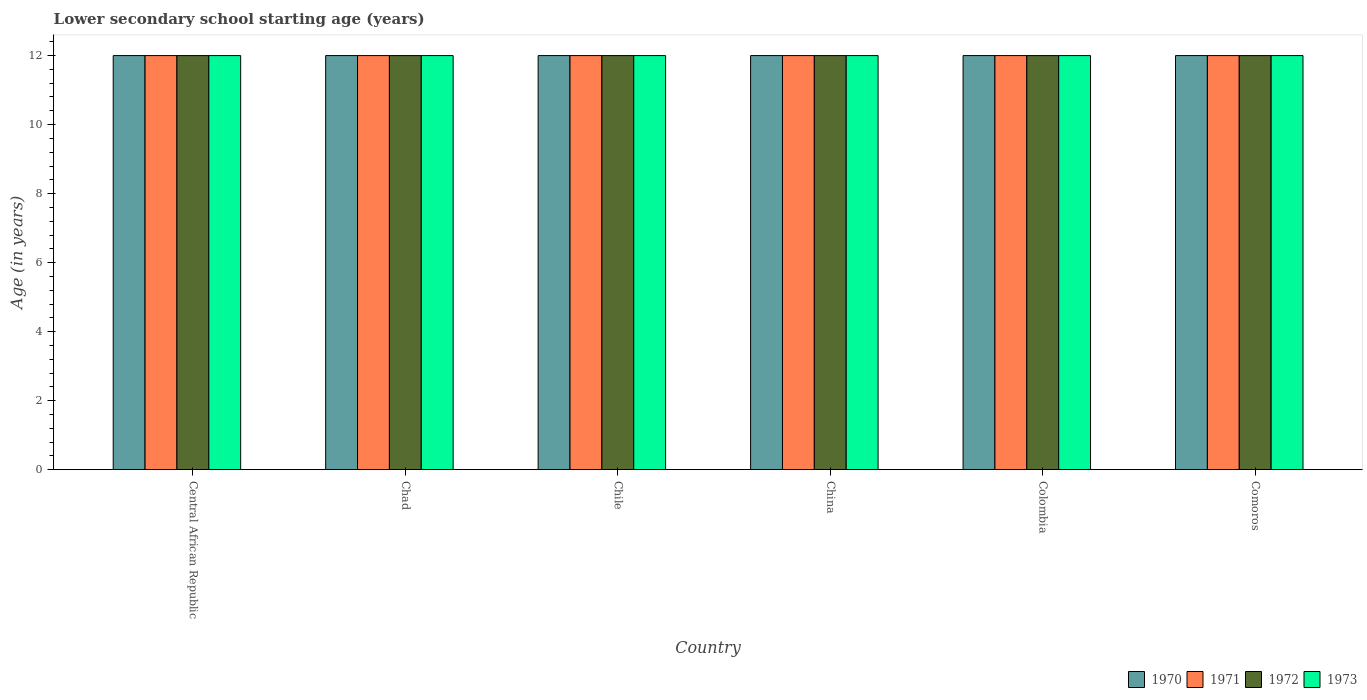Are the number of bars on each tick of the X-axis equal?
Provide a succinct answer. Yes. How many bars are there on the 4th tick from the left?
Offer a terse response. 4. In how many cases, is the number of bars for a given country not equal to the number of legend labels?
Keep it short and to the point. 0. Across all countries, what is the maximum lower secondary school starting age of children in 1971?
Keep it short and to the point. 12. In which country was the lower secondary school starting age of children in 1970 maximum?
Give a very brief answer. Central African Republic. In which country was the lower secondary school starting age of children in 1973 minimum?
Offer a terse response. Central African Republic. What is the difference between the lower secondary school starting age of children in 1971 in Colombia and the lower secondary school starting age of children in 1970 in Chile?
Your response must be concise. 0. What is the average lower secondary school starting age of children in 1970 per country?
Provide a short and direct response. 12. What is the difference between the lower secondary school starting age of children of/in 1971 and lower secondary school starting age of children of/in 1970 in Chile?
Give a very brief answer. 0. In how many countries, is the lower secondary school starting age of children in 1973 greater than 7.6 years?
Offer a terse response. 6. Is the difference between the lower secondary school starting age of children in 1971 in Central African Republic and Chile greater than the difference between the lower secondary school starting age of children in 1970 in Central African Republic and Chile?
Keep it short and to the point. No. What is the difference between the highest and the lowest lower secondary school starting age of children in 1971?
Ensure brevity in your answer.  0. Is the sum of the lower secondary school starting age of children in 1970 in Central African Republic and Comoros greater than the maximum lower secondary school starting age of children in 1971 across all countries?
Give a very brief answer. Yes. Is it the case that in every country, the sum of the lower secondary school starting age of children in 1973 and lower secondary school starting age of children in 1971 is greater than the sum of lower secondary school starting age of children in 1972 and lower secondary school starting age of children in 1970?
Provide a short and direct response. No. What is the difference between two consecutive major ticks on the Y-axis?
Your answer should be very brief. 2. Are the values on the major ticks of Y-axis written in scientific E-notation?
Your response must be concise. No. Does the graph contain grids?
Keep it short and to the point. No. How many legend labels are there?
Offer a very short reply. 4. How are the legend labels stacked?
Make the answer very short. Horizontal. What is the title of the graph?
Offer a very short reply. Lower secondary school starting age (years). What is the label or title of the Y-axis?
Keep it short and to the point. Age (in years). What is the Age (in years) in 1970 in Central African Republic?
Give a very brief answer. 12. What is the Age (in years) of 1972 in Central African Republic?
Give a very brief answer. 12. What is the Age (in years) in 1973 in Central African Republic?
Provide a succinct answer. 12. What is the Age (in years) of 1970 in Chad?
Offer a very short reply. 12. What is the Age (in years) of 1972 in Chad?
Your response must be concise. 12. What is the Age (in years) in 1973 in Chad?
Make the answer very short. 12. What is the Age (in years) in 1970 in Chile?
Offer a terse response. 12. What is the Age (in years) of 1970 in China?
Your answer should be very brief. 12. What is the Age (in years) in 1971 in China?
Offer a terse response. 12. What is the Age (in years) in 1973 in China?
Your answer should be compact. 12. What is the Age (in years) of 1972 in Colombia?
Your answer should be very brief. 12. What is the Age (in years) in 1973 in Colombia?
Give a very brief answer. 12. Across all countries, what is the maximum Age (in years) of 1970?
Offer a terse response. 12. Across all countries, what is the maximum Age (in years) in 1971?
Ensure brevity in your answer.  12. Across all countries, what is the minimum Age (in years) in 1970?
Give a very brief answer. 12. Across all countries, what is the minimum Age (in years) in 1971?
Offer a terse response. 12. What is the total Age (in years) in 1970 in the graph?
Your answer should be very brief. 72. What is the total Age (in years) of 1973 in the graph?
Your response must be concise. 72. What is the difference between the Age (in years) in 1970 in Central African Republic and that in Chad?
Provide a succinct answer. 0. What is the difference between the Age (in years) in 1971 in Central African Republic and that in Chad?
Your answer should be very brief. 0. What is the difference between the Age (in years) of 1972 in Central African Republic and that in Chad?
Keep it short and to the point. 0. What is the difference between the Age (in years) in 1973 in Central African Republic and that in Chad?
Your answer should be very brief. 0. What is the difference between the Age (in years) of 1971 in Central African Republic and that in Chile?
Offer a terse response. 0. What is the difference between the Age (in years) of 1970 in Central African Republic and that in China?
Give a very brief answer. 0. What is the difference between the Age (in years) of 1971 in Central African Republic and that in China?
Give a very brief answer. 0. What is the difference between the Age (in years) in 1973 in Central African Republic and that in China?
Offer a very short reply. 0. What is the difference between the Age (in years) of 1970 in Central African Republic and that in Colombia?
Keep it short and to the point. 0. What is the difference between the Age (in years) of 1972 in Central African Republic and that in Colombia?
Provide a succinct answer. 0. What is the difference between the Age (in years) in 1973 in Central African Republic and that in Colombia?
Ensure brevity in your answer.  0. What is the difference between the Age (in years) in 1970 in Central African Republic and that in Comoros?
Your answer should be very brief. 0. What is the difference between the Age (in years) in 1973 in Central African Republic and that in Comoros?
Ensure brevity in your answer.  0. What is the difference between the Age (in years) of 1971 in Chad and that in Chile?
Give a very brief answer. 0. What is the difference between the Age (in years) in 1972 in Chad and that in Chile?
Provide a short and direct response. 0. What is the difference between the Age (in years) of 1970 in Chad and that in China?
Your response must be concise. 0. What is the difference between the Age (in years) of 1972 in Chad and that in China?
Provide a short and direct response. 0. What is the difference between the Age (in years) of 1970 in Chad and that in Colombia?
Provide a succinct answer. 0. What is the difference between the Age (in years) in 1971 in Chad and that in Colombia?
Your response must be concise. 0. What is the difference between the Age (in years) in 1970 in Chad and that in Comoros?
Provide a succinct answer. 0. What is the difference between the Age (in years) in 1973 in Chad and that in Comoros?
Make the answer very short. 0. What is the difference between the Age (in years) of 1970 in Chile and that in China?
Your answer should be very brief. 0. What is the difference between the Age (in years) in 1971 in Chile and that in China?
Provide a succinct answer. 0. What is the difference between the Age (in years) in 1970 in Chile and that in Comoros?
Give a very brief answer. 0. What is the difference between the Age (in years) in 1972 in Chile and that in Comoros?
Your response must be concise. 0. What is the difference between the Age (in years) of 1973 in Chile and that in Comoros?
Your answer should be very brief. 0. What is the difference between the Age (in years) in 1970 in China and that in Colombia?
Give a very brief answer. 0. What is the difference between the Age (in years) of 1971 in China and that in Colombia?
Offer a terse response. 0. What is the difference between the Age (in years) in 1972 in China and that in Colombia?
Ensure brevity in your answer.  0. What is the difference between the Age (in years) in 1970 in China and that in Comoros?
Provide a succinct answer. 0. What is the difference between the Age (in years) of 1971 in China and that in Comoros?
Provide a succinct answer. 0. What is the difference between the Age (in years) of 1973 in China and that in Comoros?
Your answer should be very brief. 0. What is the difference between the Age (in years) in 1970 in Colombia and that in Comoros?
Your answer should be compact. 0. What is the difference between the Age (in years) in 1971 in Colombia and that in Comoros?
Provide a succinct answer. 0. What is the difference between the Age (in years) in 1972 in Colombia and that in Comoros?
Your answer should be compact. 0. What is the difference between the Age (in years) in 1970 in Central African Republic and the Age (in years) in 1971 in Chad?
Ensure brevity in your answer.  0. What is the difference between the Age (in years) in 1970 in Central African Republic and the Age (in years) in 1973 in Chad?
Your response must be concise. 0. What is the difference between the Age (in years) in 1971 in Central African Republic and the Age (in years) in 1972 in Chad?
Your answer should be compact. 0. What is the difference between the Age (in years) in 1971 in Central African Republic and the Age (in years) in 1973 in Chad?
Provide a short and direct response. 0. What is the difference between the Age (in years) of 1970 in Central African Republic and the Age (in years) of 1972 in Chile?
Ensure brevity in your answer.  0. What is the difference between the Age (in years) of 1972 in Central African Republic and the Age (in years) of 1973 in Chile?
Give a very brief answer. 0. What is the difference between the Age (in years) in 1972 in Central African Republic and the Age (in years) in 1973 in China?
Ensure brevity in your answer.  0. What is the difference between the Age (in years) in 1970 in Central African Republic and the Age (in years) in 1972 in Colombia?
Offer a terse response. 0. What is the difference between the Age (in years) of 1971 in Central African Republic and the Age (in years) of 1972 in Colombia?
Ensure brevity in your answer.  0. What is the difference between the Age (in years) in 1971 in Central African Republic and the Age (in years) in 1973 in Colombia?
Make the answer very short. 0. What is the difference between the Age (in years) in 1970 in Central African Republic and the Age (in years) in 1971 in Comoros?
Keep it short and to the point. 0. What is the difference between the Age (in years) in 1970 in Central African Republic and the Age (in years) in 1973 in Comoros?
Provide a short and direct response. 0. What is the difference between the Age (in years) of 1971 in Central African Republic and the Age (in years) of 1972 in Comoros?
Ensure brevity in your answer.  0. What is the difference between the Age (in years) in 1970 in Chad and the Age (in years) in 1971 in Chile?
Give a very brief answer. 0. What is the difference between the Age (in years) of 1970 in Chad and the Age (in years) of 1972 in Chile?
Ensure brevity in your answer.  0. What is the difference between the Age (in years) in 1970 in Chad and the Age (in years) in 1973 in Chile?
Provide a succinct answer. 0. What is the difference between the Age (in years) of 1971 in Chad and the Age (in years) of 1972 in Chile?
Provide a succinct answer. 0. What is the difference between the Age (in years) in 1970 in Chad and the Age (in years) in 1971 in China?
Your answer should be very brief. 0. What is the difference between the Age (in years) in 1970 in Chad and the Age (in years) in 1973 in China?
Your answer should be compact. 0. What is the difference between the Age (in years) in 1972 in Chad and the Age (in years) in 1973 in China?
Offer a very short reply. 0. What is the difference between the Age (in years) in 1970 in Chad and the Age (in years) in 1971 in Colombia?
Provide a short and direct response. 0. What is the difference between the Age (in years) of 1970 in Chad and the Age (in years) of 1972 in Colombia?
Your response must be concise. 0. What is the difference between the Age (in years) of 1971 in Chad and the Age (in years) of 1972 in Colombia?
Provide a succinct answer. 0. What is the difference between the Age (in years) of 1970 in Chad and the Age (in years) of 1973 in Comoros?
Provide a short and direct response. 0. What is the difference between the Age (in years) of 1971 in Chad and the Age (in years) of 1972 in Comoros?
Provide a succinct answer. 0. What is the difference between the Age (in years) in 1971 in Chad and the Age (in years) in 1973 in Comoros?
Make the answer very short. 0. What is the difference between the Age (in years) in 1972 in Chad and the Age (in years) in 1973 in Comoros?
Keep it short and to the point. 0. What is the difference between the Age (in years) in 1970 in Chile and the Age (in years) in 1971 in China?
Ensure brevity in your answer.  0. What is the difference between the Age (in years) in 1971 in Chile and the Age (in years) in 1973 in China?
Offer a terse response. 0. What is the difference between the Age (in years) in 1972 in Chile and the Age (in years) in 1973 in China?
Provide a short and direct response. 0. What is the difference between the Age (in years) in 1970 in Chile and the Age (in years) in 1972 in Colombia?
Provide a succinct answer. 0. What is the difference between the Age (in years) in 1970 in Chile and the Age (in years) in 1973 in Colombia?
Offer a very short reply. 0. What is the difference between the Age (in years) in 1971 in Chile and the Age (in years) in 1973 in Colombia?
Provide a succinct answer. 0. What is the difference between the Age (in years) in 1972 in Chile and the Age (in years) in 1973 in Colombia?
Your answer should be compact. 0. What is the difference between the Age (in years) of 1970 in Chile and the Age (in years) of 1971 in Comoros?
Offer a very short reply. 0. What is the difference between the Age (in years) of 1970 in Chile and the Age (in years) of 1972 in Comoros?
Give a very brief answer. 0. What is the difference between the Age (in years) of 1971 in Chile and the Age (in years) of 1972 in Comoros?
Give a very brief answer. 0. What is the difference between the Age (in years) in 1971 in Chile and the Age (in years) in 1973 in Comoros?
Offer a terse response. 0. What is the difference between the Age (in years) in 1972 in Chile and the Age (in years) in 1973 in Comoros?
Ensure brevity in your answer.  0. What is the difference between the Age (in years) of 1970 in China and the Age (in years) of 1971 in Colombia?
Offer a very short reply. 0. What is the difference between the Age (in years) of 1971 in China and the Age (in years) of 1973 in Colombia?
Make the answer very short. 0. What is the difference between the Age (in years) of 1970 in China and the Age (in years) of 1971 in Comoros?
Your answer should be compact. 0. What is the difference between the Age (in years) in 1970 in China and the Age (in years) in 1972 in Comoros?
Offer a very short reply. 0. What is the difference between the Age (in years) of 1970 in China and the Age (in years) of 1973 in Comoros?
Keep it short and to the point. 0. What is the difference between the Age (in years) of 1971 in China and the Age (in years) of 1972 in Comoros?
Offer a terse response. 0. What is the difference between the Age (in years) in 1972 in China and the Age (in years) in 1973 in Comoros?
Provide a succinct answer. 0. What is the difference between the Age (in years) of 1970 in Colombia and the Age (in years) of 1971 in Comoros?
Your answer should be very brief. 0. What is the difference between the Age (in years) in 1970 in Colombia and the Age (in years) in 1972 in Comoros?
Your response must be concise. 0. What is the difference between the Age (in years) of 1971 in Colombia and the Age (in years) of 1973 in Comoros?
Ensure brevity in your answer.  0. What is the average Age (in years) in 1970 per country?
Offer a very short reply. 12. What is the average Age (in years) in 1971 per country?
Your response must be concise. 12. What is the average Age (in years) of 1973 per country?
Give a very brief answer. 12. What is the difference between the Age (in years) in 1970 and Age (in years) in 1971 in Central African Republic?
Ensure brevity in your answer.  0. What is the difference between the Age (in years) in 1970 and Age (in years) in 1971 in Chad?
Your response must be concise. 0. What is the difference between the Age (in years) in 1970 and Age (in years) in 1972 in Chad?
Provide a short and direct response. 0. What is the difference between the Age (in years) in 1971 and Age (in years) in 1972 in Chad?
Give a very brief answer. 0. What is the difference between the Age (in years) in 1971 and Age (in years) in 1973 in Chad?
Ensure brevity in your answer.  0. What is the difference between the Age (in years) of 1971 and Age (in years) of 1973 in Chile?
Offer a very short reply. 0. What is the difference between the Age (in years) in 1970 and Age (in years) in 1971 in China?
Offer a very short reply. 0. What is the difference between the Age (in years) of 1970 and Age (in years) of 1973 in China?
Provide a short and direct response. 0. What is the difference between the Age (in years) in 1971 and Age (in years) in 1973 in China?
Provide a succinct answer. 0. What is the difference between the Age (in years) in 1970 and Age (in years) in 1971 in Colombia?
Your answer should be very brief. 0. What is the difference between the Age (in years) in 1972 and Age (in years) in 1973 in Colombia?
Provide a succinct answer. 0. What is the difference between the Age (in years) of 1970 and Age (in years) of 1971 in Comoros?
Ensure brevity in your answer.  0. What is the difference between the Age (in years) of 1970 and Age (in years) of 1973 in Comoros?
Give a very brief answer. 0. What is the difference between the Age (in years) in 1971 and Age (in years) in 1973 in Comoros?
Offer a very short reply. 0. What is the difference between the Age (in years) in 1972 and Age (in years) in 1973 in Comoros?
Provide a succinct answer. 0. What is the ratio of the Age (in years) in 1970 in Central African Republic to that in Chad?
Offer a very short reply. 1. What is the ratio of the Age (in years) in 1972 in Central African Republic to that in Chad?
Provide a short and direct response. 1. What is the ratio of the Age (in years) of 1970 in Central African Republic to that in Chile?
Give a very brief answer. 1. What is the ratio of the Age (in years) in 1972 in Central African Republic to that in Chile?
Your answer should be compact. 1. What is the ratio of the Age (in years) of 1973 in Central African Republic to that in Chile?
Give a very brief answer. 1. What is the ratio of the Age (in years) in 1970 in Central African Republic to that in China?
Give a very brief answer. 1. What is the ratio of the Age (in years) of 1972 in Central African Republic to that in China?
Offer a very short reply. 1. What is the ratio of the Age (in years) in 1973 in Central African Republic to that in China?
Your answer should be compact. 1. What is the ratio of the Age (in years) in 1970 in Central African Republic to that in Colombia?
Offer a terse response. 1. What is the ratio of the Age (in years) of 1972 in Central African Republic to that in Colombia?
Provide a short and direct response. 1. What is the ratio of the Age (in years) of 1973 in Central African Republic to that in Colombia?
Keep it short and to the point. 1. What is the ratio of the Age (in years) in 1970 in Central African Republic to that in Comoros?
Offer a terse response. 1. What is the ratio of the Age (in years) in 1972 in Central African Republic to that in Comoros?
Give a very brief answer. 1. What is the ratio of the Age (in years) of 1970 in Chad to that in Chile?
Your answer should be very brief. 1. What is the ratio of the Age (in years) in 1972 in Chad to that in Chile?
Your answer should be very brief. 1. What is the ratio of the Age (in years) in 1973 in Chad to that in Chile?
Provide a short and direct response. 1. What is the ratio of the Age (in years) in 1970 in Chad to that in China?
Offer a terse response. 1. What is the ratio of the Age (in years) in 1971 in Chad to that in China?
Offer a very short reply. 1. What is the ratio of the Age (in years) in 1972 in Chad to that in China?
Your response must be concise. 1. What is the ratio of the Age (in years) of 1970 in Chad to that in Colombia?
Ensure brevity in your answer.  1. What is the ratio of the Age (in years) in 1971 in Chad to that in Colombia?
Make the answer very short. 1. What is the ratio of the Age (in years) in 1973 in Chad to that in Colombia?
Your answer should be very brief. 1. What is the ratio of the Age (in years) in 1970 in Chad to that in Comoros?
Offer a terse response. 1. What is the ratio of the Age (in years) of 1971 in Chad to that in Comoros?
Provide a succinct answer. 1. What is the ratio of the Age (in years) in 1971 in Chile to that in China?
Offer a very short reply. 1. What is the ratio of the Age (in years) of 1973 in Chile to that in China?
Make the answer very short. 1. What is the ratio of the Age (in years) in 1972 in Chile to that in Comoros?
Provide a succinct answer. 1. What is the ratio of the Age (in years) of 1970 in China to that in Colombia?
Your answer should be compact. 1. What is the ratio of the Age (in years) in 1971 in China to that in Colombia?
Your answer should be compact. 1. What is the ratio of the Age (in years) in 1972 in China to that in Colombia?
Ensure brevity in your answer.  1. What is the ratio of the Age (in years) of 1973 in China to that in Colombia?
Your answer should be compact. 1. What is the ratio of the Age (in years) in 1971 in China to that in Comoros?
Offer a very short reply. 1. What is the ratio of the Age (in years) in 1973 in China to that in Comoros?
Give a very brief answer. 1. What is the ratio of the Age (in years) in 1972 in Colombia to that in Comoros?
Ensure brevity in your answer.  1. What is the ratio of the Age (in years) of 1973 in Colombia to that in Comoros?
Your answer should be compact. 1. What is the difference between the highest and the second highest Age (in years) of 1970?
Give a very brief answer. 0. What is the difference between the highest and the lowest Age (in years) of 1970?
Keep it short and to the point. 0. What is the difference between the highest and the lowest Age (in years) of 1971?
Offer a terse response. 0. What is the difference between the highest and the lowest Age (in years) in 1973?
Offer a very short reply. 0. 